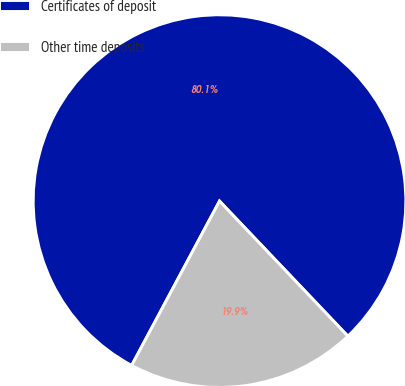<chart> <loc_0><loc_0><loc_500><loc_500><pie_chart><fcel>Certificates of deposit<fcel>Other time deposits<nl><fcel>80.09%<fcel>19.91%<nl></chart> 